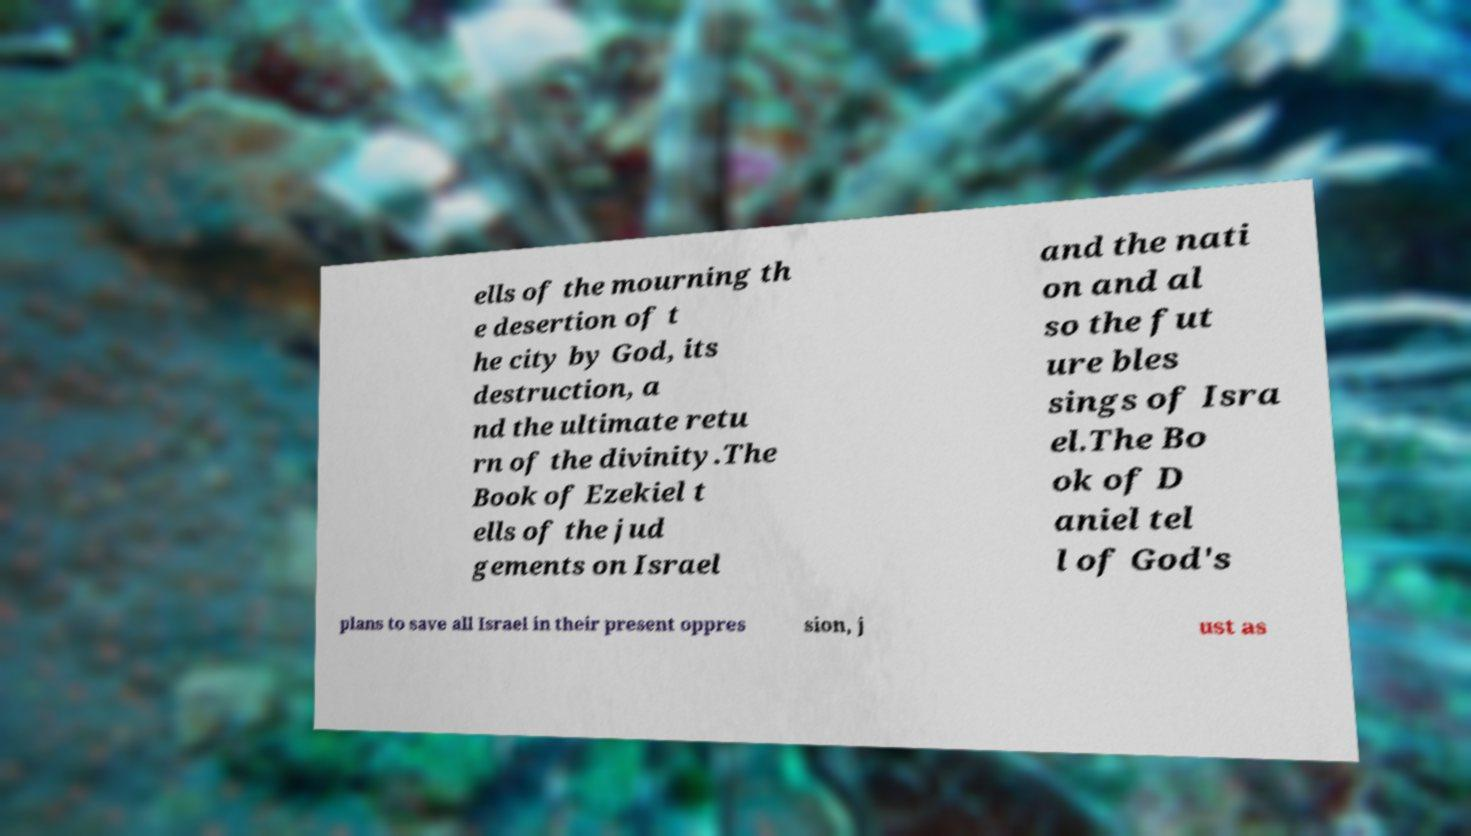For documentation purposes, I need the text within this image transcribed. Could you provide that? ells of the mourning th e desertion of t he city by God, its destruction, a nd the ultimate retu rn of the divinity.The Book of Ezekiel t ells of the jud gements on Israel and the nati on and al so the fut ure bles sings of Isra el.The Bo ok of D aniel tel l of God's plans to save all Israel in their present oppres sion, j ust as 